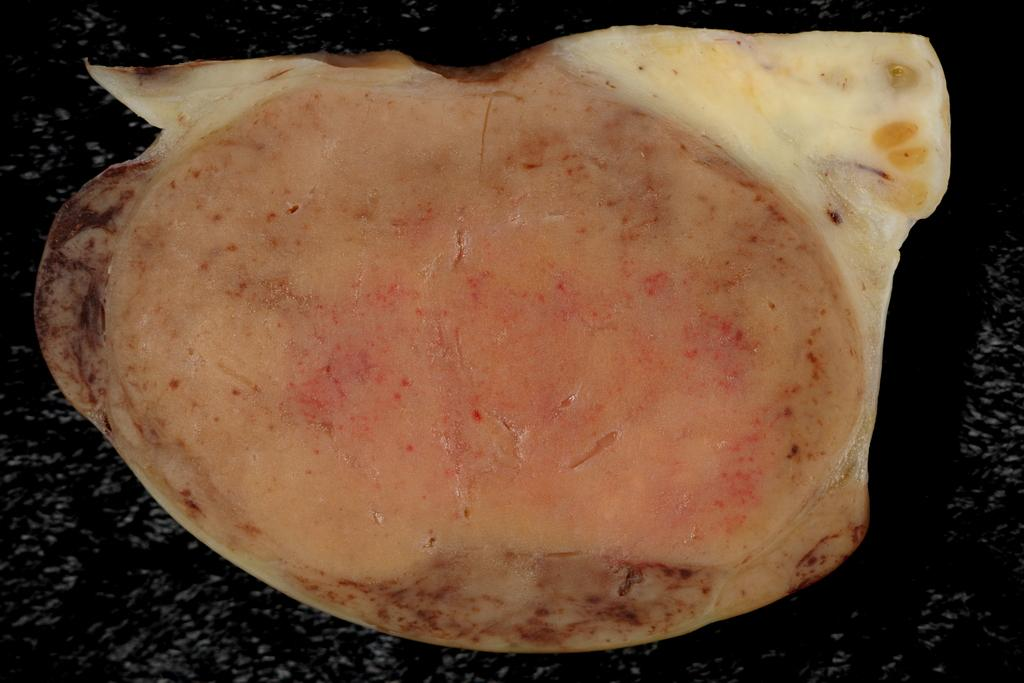What is the main subject of the image? The main subject of the image is food. What can be observed about the surface on which the food is placed? The food is placed on a black color surface. Is there a crown placed on top of the food in the image? No, there is no crown present in the image. Can you touch the food in the image? The image is a static representation, so you cannot physically touch the food in the image. 